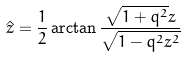<formula> <loc_0><loc_0><loc_500><loc_500>\hat { z } = \frac { 1 } { 2 } \arctan \frac { \sqrt { 1 + q ^ { 2 } } z } { \sqrt { 1 - q ^ { 2 } z ^ { 2 } } }</formula> 